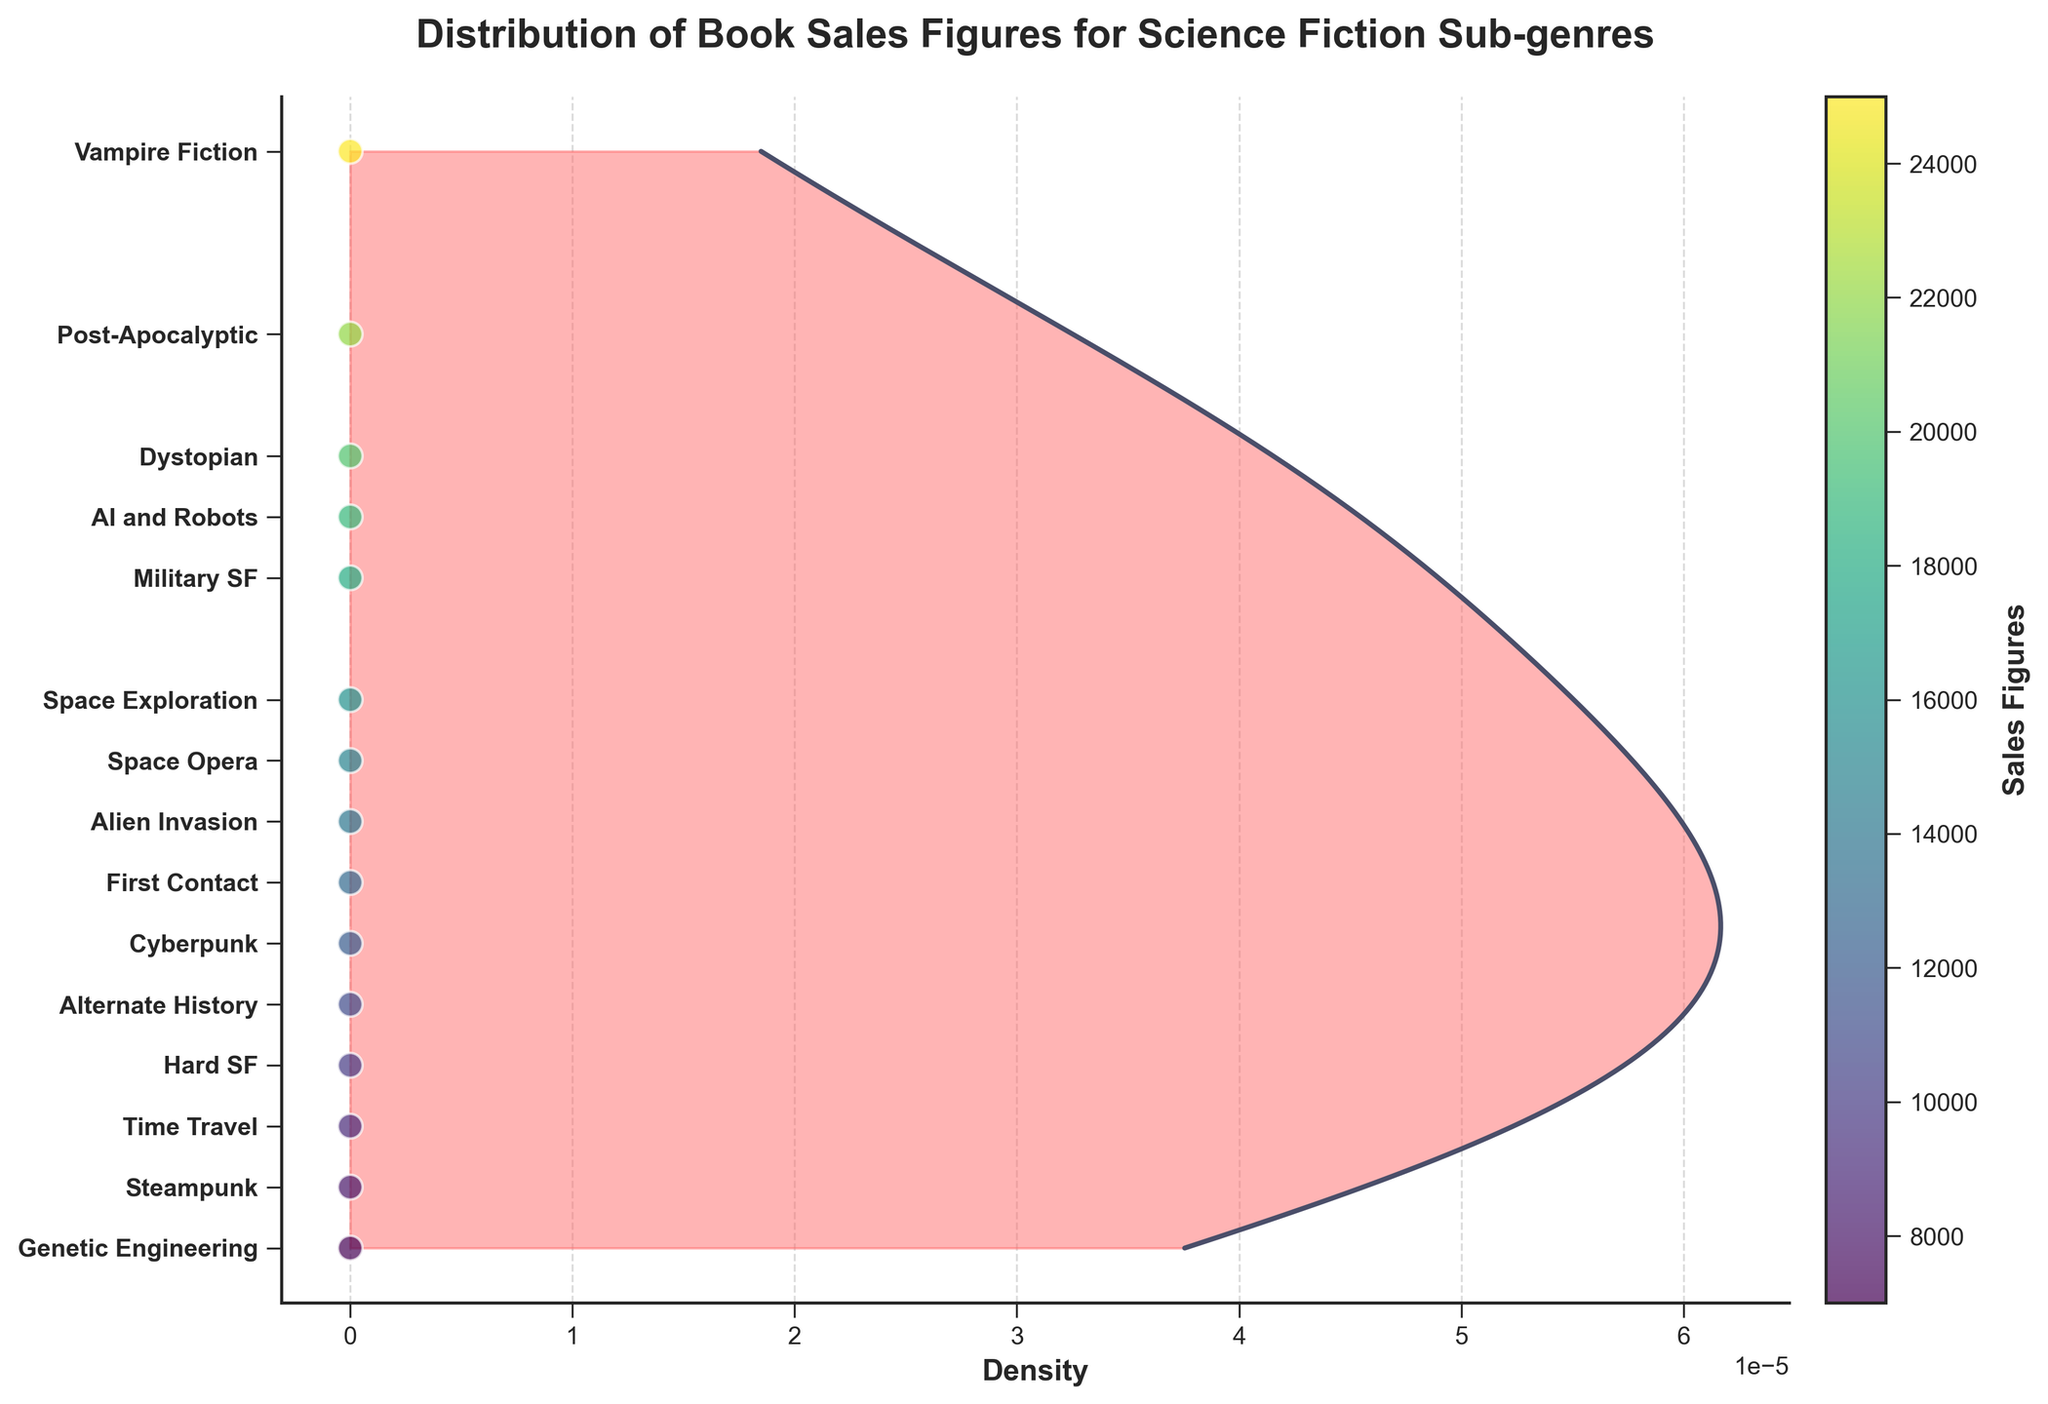What is the title of the plot? The title is usually located at the top of the plot. In this figure, the title is "Distribution of Book Sales Figures for Science Fiction Sub-genres".
Answer: Distribution of Book Sales Figures for Science Fiction Sub-genres Which sub-genre has the highest sales figure? Identify the point on the plot that is plotted highest on the y-axis. The highest point corresponds to "Vampire Fiction" with a sales figure of 25000.
Answer: Vampire Fiction How many sub-genres are represented in the plot? Count the number of unique labels on the y-axis or the number of scatter points. There are 15 unique sub-genres labeled.
Answer: 15 What is the range of sales figures in the data? The range is determined by the minimum and maximum value on the y-axis. The sales figures range from 7000 to 25000.
Answer: 7000 to 25000 Which sub-genre has the lowest sales figure? Identify the point on the plot that is plotted lowest on the y-axis. The lowest point corresponds to "Genetic Engineering" with a sales figure of 7000.
Answer: Genetic Engineering Compare the sales figures of "Alien Invasion" and "First Contact". Which one is higher? Locate both points on the y-axis. "Alien Invasion" has a sales figure of 14000, while "First Contact" has a sales figure of 13000. 14000 is higher than 13000.
Answer: Alien Invasion What is the approximate median sales figure? To find the median, arrange the sales figures in ascending order and find the middle value. The middle value between the 7th (13000) and 8th (14000) values in a sorted list of 15 data points is (13000 + 14000) / 2.
Answer: 13500 Which sub-genres fall below the median sales figure? Identify the sub-genres corresponding to sales figures below 13500. They are "Hard SF" (10000), "Time Travel" (9000), "Steampunk" (8000), "Alternate History" (11000), "First Contact" (13000), and "Genetic Engineering" (7000).
Answer: Hard SF, Time Travel, Steampunk, Alternate History, First Contact, Genetic Engineering Which sub-genre's sales figure is closest to the mean sales figure? Calculate the mean of all sales figures, sum is 184000 and there are 15 data points, mean = 184000/15 = ~12267. "Cyberpunk" (12000) is closest to this value.
Answer: Cyberpunk What's the general trend shown by the density plot? The density plot shows the distribution of sales figures, with peaks indicating areas with higher density. The plot most likely shows more density around the lower and mid-range sales figures.
Answer: Higher density at lower to mid-range sales figures 